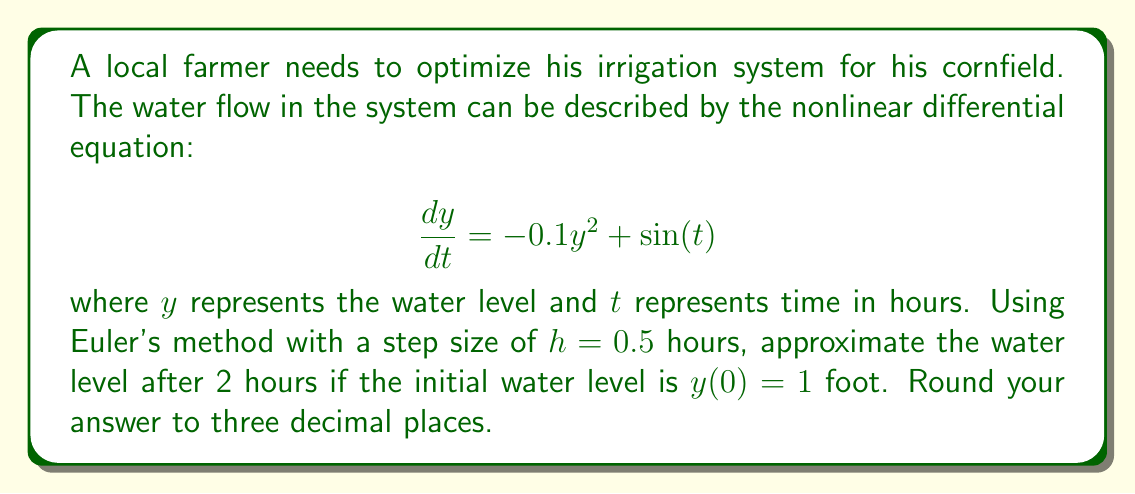Give your solution to this math problem. Let's solve this step-by-step using Euler's method:

1) Euler's method is given by the formula:
   $$y_{n+1} = y_n + hf(t_n, y_n)$$
   where $f(t, y) = -0.1y^2 + \sin(t)$

2) We're given:
   Initial condition: $y_0 = 1$
   Step size: $h = 0.5$
   Time interval: $[0, 2]$

3) We need to perform 4 iterations (2 hours / 0.5 hour steps = 4 steps)

4) First iteration (t = 0 to t = 0.5):
   $y_1 = y_0 + h(-0.1y_0^2 + \sin(0))$
   $y_1 = 1 + 0.5(-0.1(1)^2 + 0) = 0.95$

5) Second iteration (t = 0.5 to t = 1):
   $y_2 = y_1 + h(-0.1y_1^2 + \sin(0.5))$
   $y_2 = 0.95 + 0.5(-0.1(0.95)^2 + \sin(0.5)) = 1.149$

6) Third iteration (t = 1 to t = 1.5):
   $y_3 = y_2 + h(-0.1y_2^2 + \sin(1))$
   $y_3 = 1.149 + 0.5(-0.1(1.149)^2 + \sin(1)) = 1.426$

7) Fourth iteration (t = 1.5 to t = 2):
   $y_4 = y_3 + h(-0.1y_3^2 + \sin(1.5))$
   $y_4 = 1.426 + 0.5(-0.1(1.426)^2 + \sin(1.5)) = 1.622$

8) Rounding to three decimal places: 1.622
Answer: 1.622 feet 